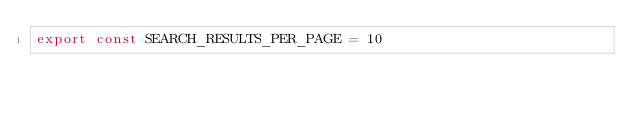Convert code to text. <code><loc_0><loc_0><loc_500><loc_500><_JavaScript_>export const SEARCH_RESULTS_PER_PAGE = 10
</code> 